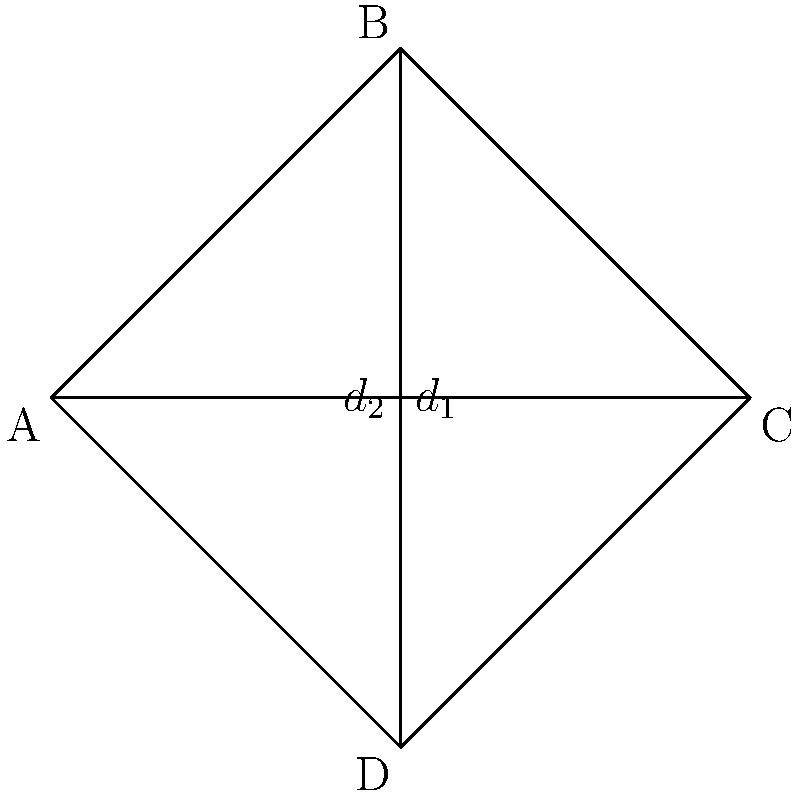At your local pub, you notice a rhombus-shaped beer mat. Being a curious football fan, you wonder about its dimensions. The diagonals of the rhombus measure 8 cm and 6 cm. Calculate the perimeter of the beer mat. Let's approach this step-by-step:

1) In a rhombus, the diagonals bisect each other at right angles. This creates four congruent right triangles.

2) Let's focus on one of these right triangles. If we know the lengths of its legs (half of each diagonal), we can find the length of its hypotenuse, which is a side of the rhombus.

3) Let $d_1 = 8$ cm and $d_2 = 6$ cm be the diagonals.

4) In our right triangle, the legs are $\frac{d_1}{2} = 4$ cm and $\frac{d_2}{2} = 3$ cm.

5) We can use the Pythagorean theorem to find the length of a side (s):

   $$s^2 = (\frac{d_1}{2})^2 + (\frac{d_2}{2})^2$$
   $$s^2 = 4^2 + 3^2 = 16 + 9 = 25$$
   $$s = \sqrt{25} = 5$$

6) So each side of the rhombus is 5 cm long.

7) The perimeter of a rhombus is the sum of all four sides. Since all sides are equal:

   Perimeter $= 4s = 4 \times 5 = 20$ cm

Therefore, the perimeter of the beer mat is 20 cm.
Answer: 20 cm 